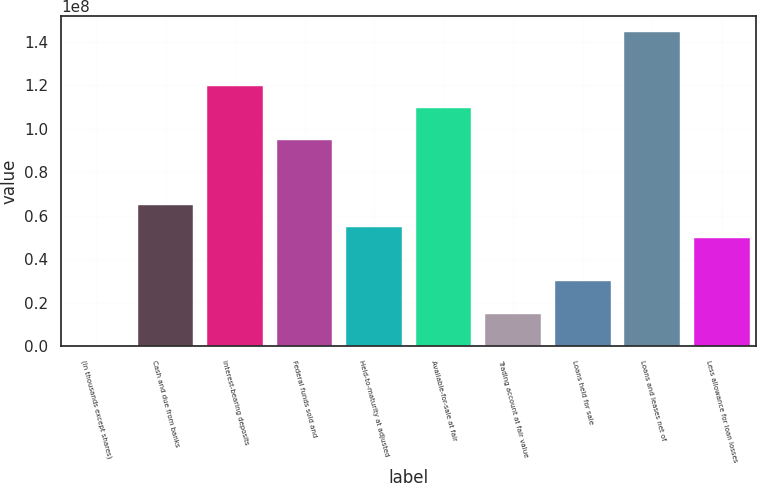<chart> <loc_0><loc_0><loc_500><loc_500><bar_chart><fcel>(In thousands except shares)<fcel>Cash and due from banks<fcel>Interest-bearing deposits<fcel>Federal funds sold and<fcel>Held-to-maturity at adjusted<fcel>Available-for-sale at fair<fcel>Trading account at fair value<fcel>Loans held for sale<fcel>Loans and leases net of<fcel>Less allowance for loan losses<nl><fcel>2014<fcel>6.47905e+07<fcel>1.19612e+08<fcel>9.46929e+07<fcel>5.48231e+07<fcel>1.09644e+08<fcel>1.49532e+07<fcel>2.99044e+07<fcel>1.4453e+08<fcel>4.98393e+07<nl></chart> 